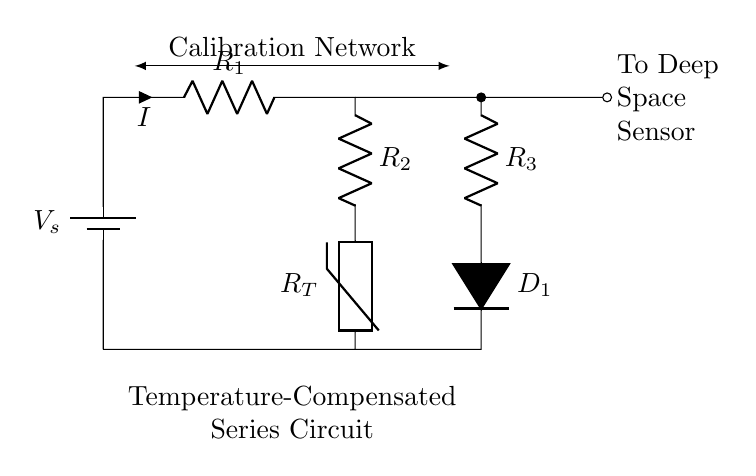What are the components in this circuit? The components in the circuit include a voltage source, two resistors, a thermistor, and a diode. Each component can be identified by their symbols in the circuit diagram.
Answer: voltage source, two resistors, thermistor, diode What is the role of the thermistor in this circuit? The thermistor is used for temperature compensation, meaning it changes resistance based on temperature variations, which helps calibrate the sensor's readings.
Answer: temperature compensation What is the current direction indicated in the circuit? The current direction is shown by the arrow marked with "I," indicating that it flows from the voltage source through the resistors and the thermistor back to the source.
Answer: from voltage source to ground What is the total resistance in the series part of this circuit? In a series circuit, the total resistance is the sum of all individual resistances. We have R1, R2, R3, and the resistance of the thermistor.
Answer: R1 + R2 + R3 + R_T How does temperature affect the thermistor's resistance and the current flow? Increasing temperature typically decreases the resistance of the thermistor, which in turn increases the current flow in the circuit according to Ohm's Law. The relationship is inverse due to the thermistor's negative temperature coefficient.
Answer: increases current flow Where does the calibration network connect in the circuit? The calibration network connects between the voltage source and the first resistor, creating a pathway for the current to flow for sensor calibration purposes.
Answer: between voltage source and R1 What is the purpose of the diode in this circuit? The diode allows current to flow in one direction, protecting the circuit from reverse polarity that could damage other components.
Answer: protects against reverse polarity 